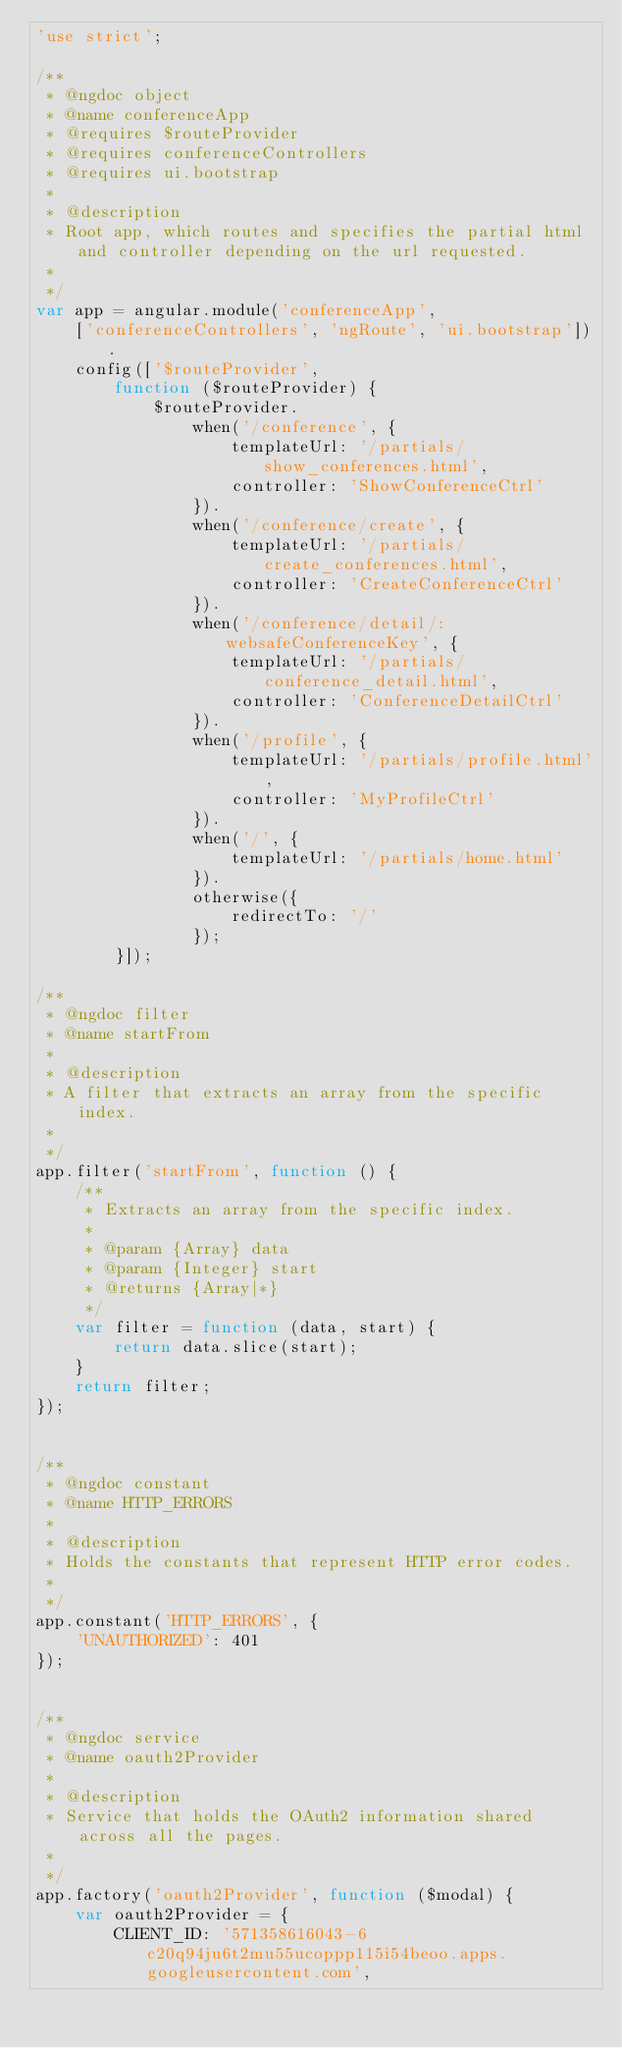Convert code to text. <code><loc_0><loc_0><loc_500><loc_500><_JavaScript_>'use strict';

/**
 * @ngdoc object
 * @name conferenceApp
 * @requires $routeProvider
 * @requires conferenceControllers
 * @requires ui.bootstrap
 *
 * @description
 * Root app, which routes and specifies the partial html and controller depending on the url requested.
 *
 */
var app = angular.module('conferenceApp',
    ['conferenceControllers', 'ngRoute', 'ui.bootstrap']).
    config(['$routeProvider',
        function ($routeProvider) {
            $routeProvider.
                when('/conference', {
                    templateUrl: '/partials/show_conferences.html',
                    controller: 'ShowConferenceCtrl'
                }).
                when('/conference/create', {
                    templateUrl: '/partials/create_conferences.html',
                    controller: 'CreateConferenceCtrl'
                }).
                when('/conference/detail/:websafeConferenceKey', {
                    templateUrl: '/partials/conference_detail.html',
                    controller: 'ConferenceDetailCtrl'
                }).
                when('/profile', {
                    templateUrl: '/partials/profile.html',
                    controller: 'MyProfileCtrl'
                }).
                when('/', {
                    templateUrl: '/partials/home.html'
                }).
                otherwise({
                    redirectTo: '/'
                });
        }]);

/**
 * @ngdoc filter
 * @name startFrom
 *
 * @description
 * A filter that extracts an array from the specific index.
 *
 */
app.filter('startFrom', function () {
    /**
     * Extracts an array from the specific index.
     *
     * @param {Array} data
     * @param {Integer} start
     * @returns {Array|*}
     */
    var filter = function (data, start) {
        return data.slice(start);
    }
    return filter;
});


/**
 * @ngdoc constant
 * @name HTTP_ERRORS
 *
 * @description
 * Holds the constants that represent HTTP error codes.
 *
 */
app.constant('HTTP_ERRORS', {
    'UNAUTHORIZED': 401
});


/**
 * @ngdoc service
 * @name oauth2Provider
 *
 * @description
 * Service that holds the OAuth2 information shared across all the pages.
 *
 */
app.factory('oauth2Provider', function ($modal) {
    var oauth2Provider = {
        CLIENT_ID: '571358616043-6c20q94ju6t2mu55ucoppp115i54beoo.apps.googleusercontent.com',</code> 